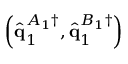<formula> <loc_0><loc_0><loc_500><loc_500>\left ( \hat { q } _ { 1 } ^ { A _ { 1 } \dagger } , \hat { q } _ { 1 } ^ { B _ { 1 } \dagger } \right )</formula> 